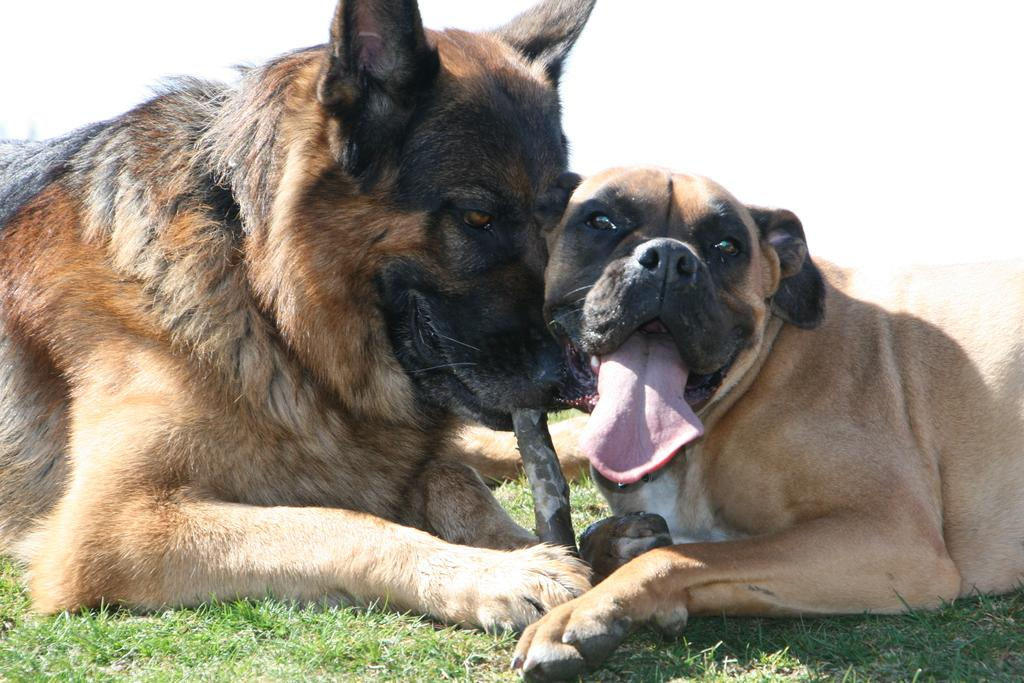How many dogs are in the image? There are two dogs in the image. What are the dogs doing in the image? The dogs are sitting on the grass. What type of holiday is the dog celebrating in the image? There is no indication of a holiday in the image, as it only features two dogs sitting on the grass. 